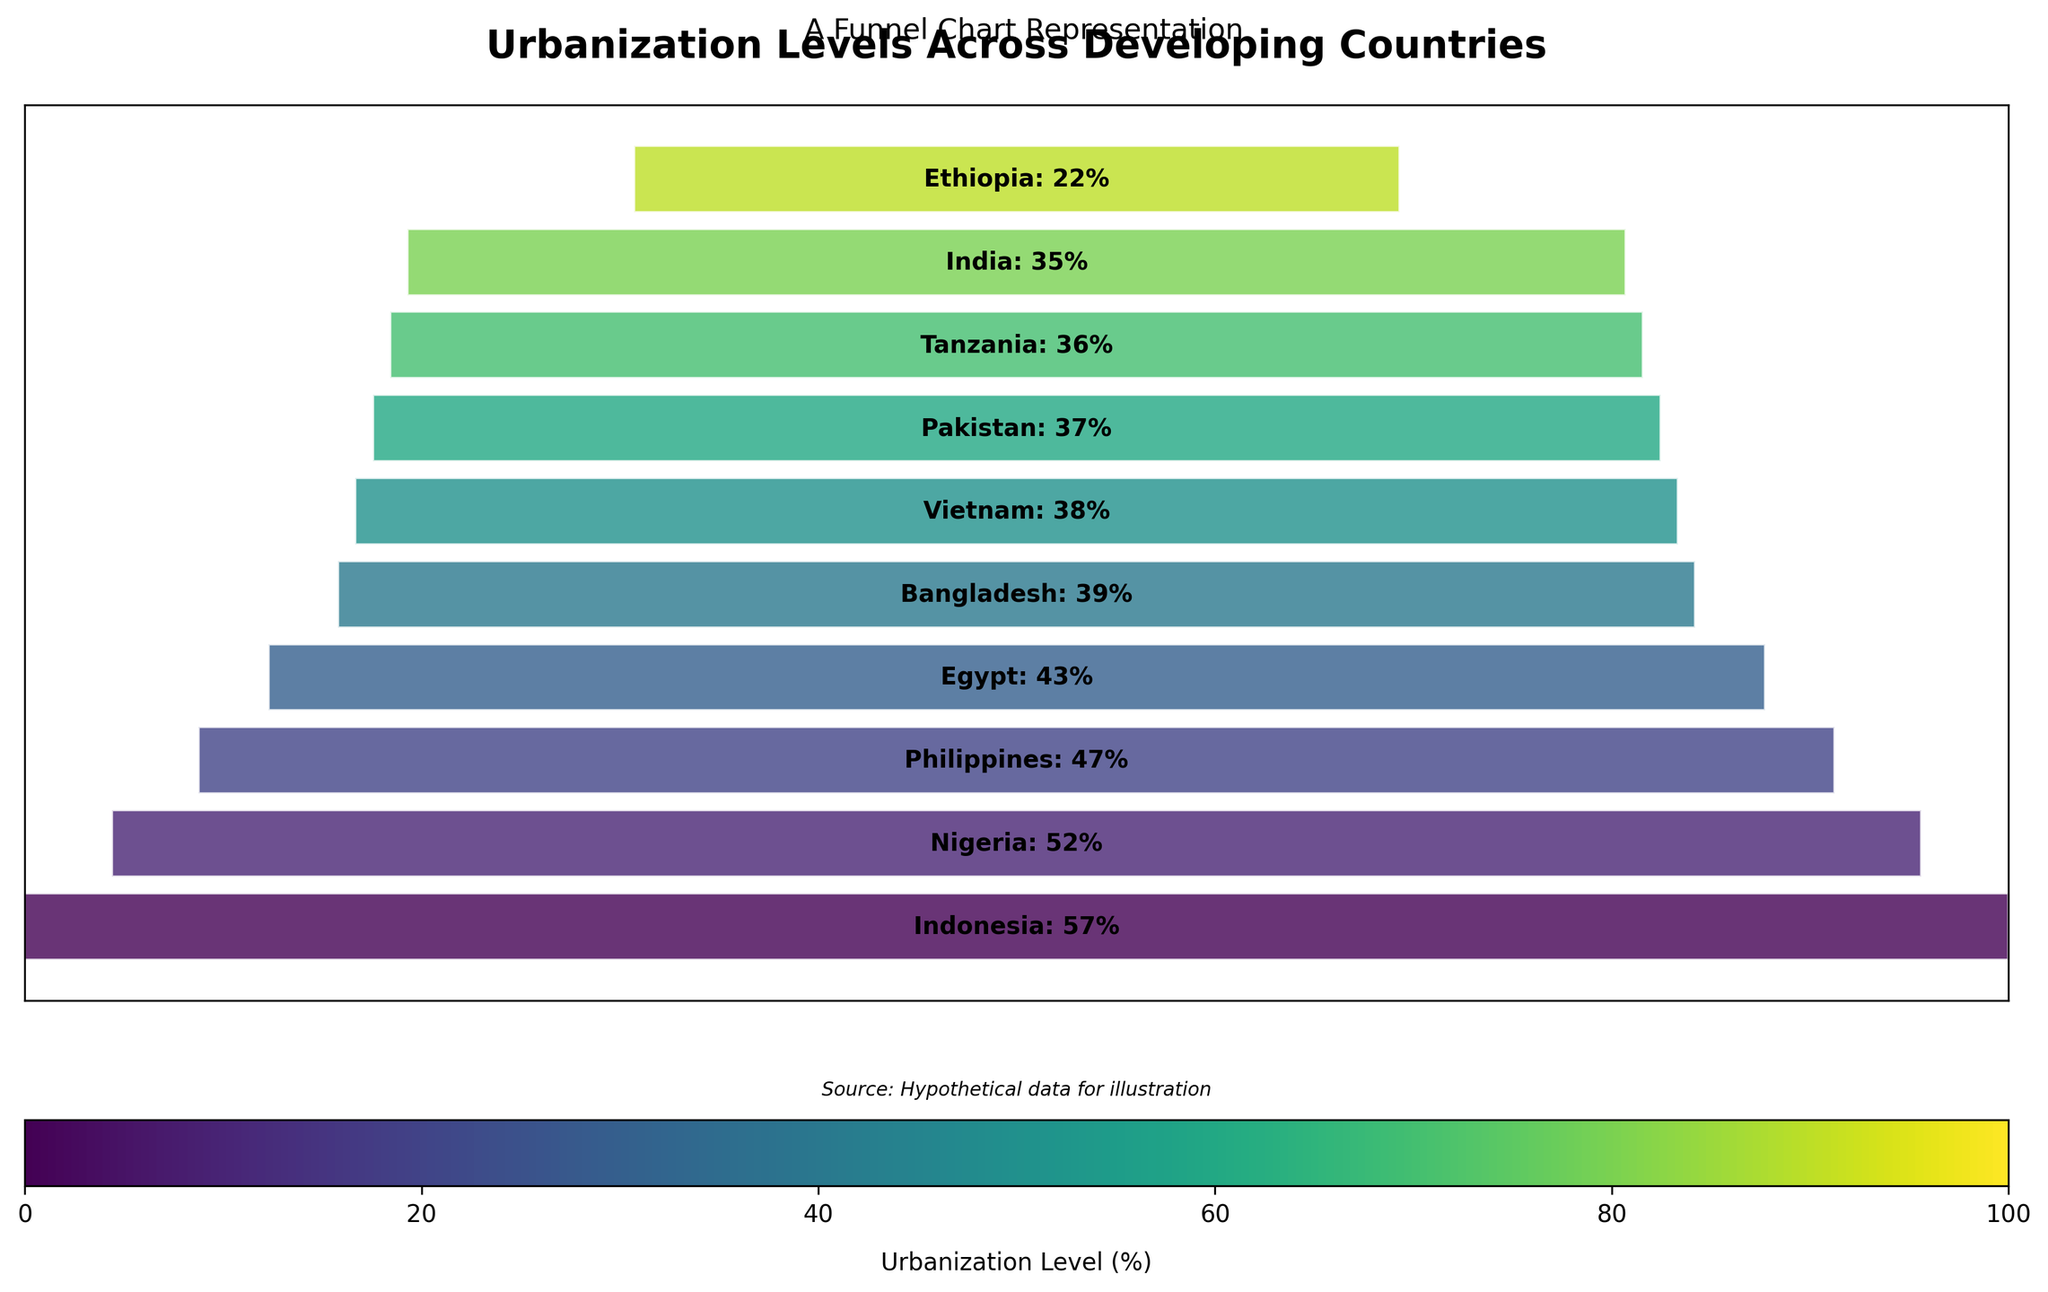What's the title of the chart? The title is placed at the top of the chart, and it reads "Urbanization Levels Across Developing Countries".
Answer: Urbanization Levels Across Developing Countries How many countries are represented in the chart? By counting the number of segments in the funnel chart, we see that there are 10 different segments, each representing a country.
Answer: 10 Which country has the highest urbanization level, and what is it? The chart's bars are ordered by urbanization levels from highest to lowest. The first (widest) segment represents Indonesia at 57%.
Answer: Indonesia, 57% What is the urbanization level of Ethiopia? Locate the segment labeled "Ethiopia", which shows the urbanization level as 22%.
Answer: 22% Which country shows an urbanization level closest to 40%? By examining the funnel chart, locate the countries with urbanization levels close to 40%. Bangladesh at 39% and Vietnam at 38% are closest.
Answer: Bangladesh, 39%; Vietnam, 38% Are there more countries with urbanization levels above or below the average level? The average urbanization level is 40.6%. By inspecting the chart, five countries (Indonesia, Nigeria, Philippines, Egypt, and Bangladesh) are above this level, and five (India, Pakistan, Vietnam, Tanzania, and Ethiopia) are below this level.
Answer: Equal (5 above, 5 below) 